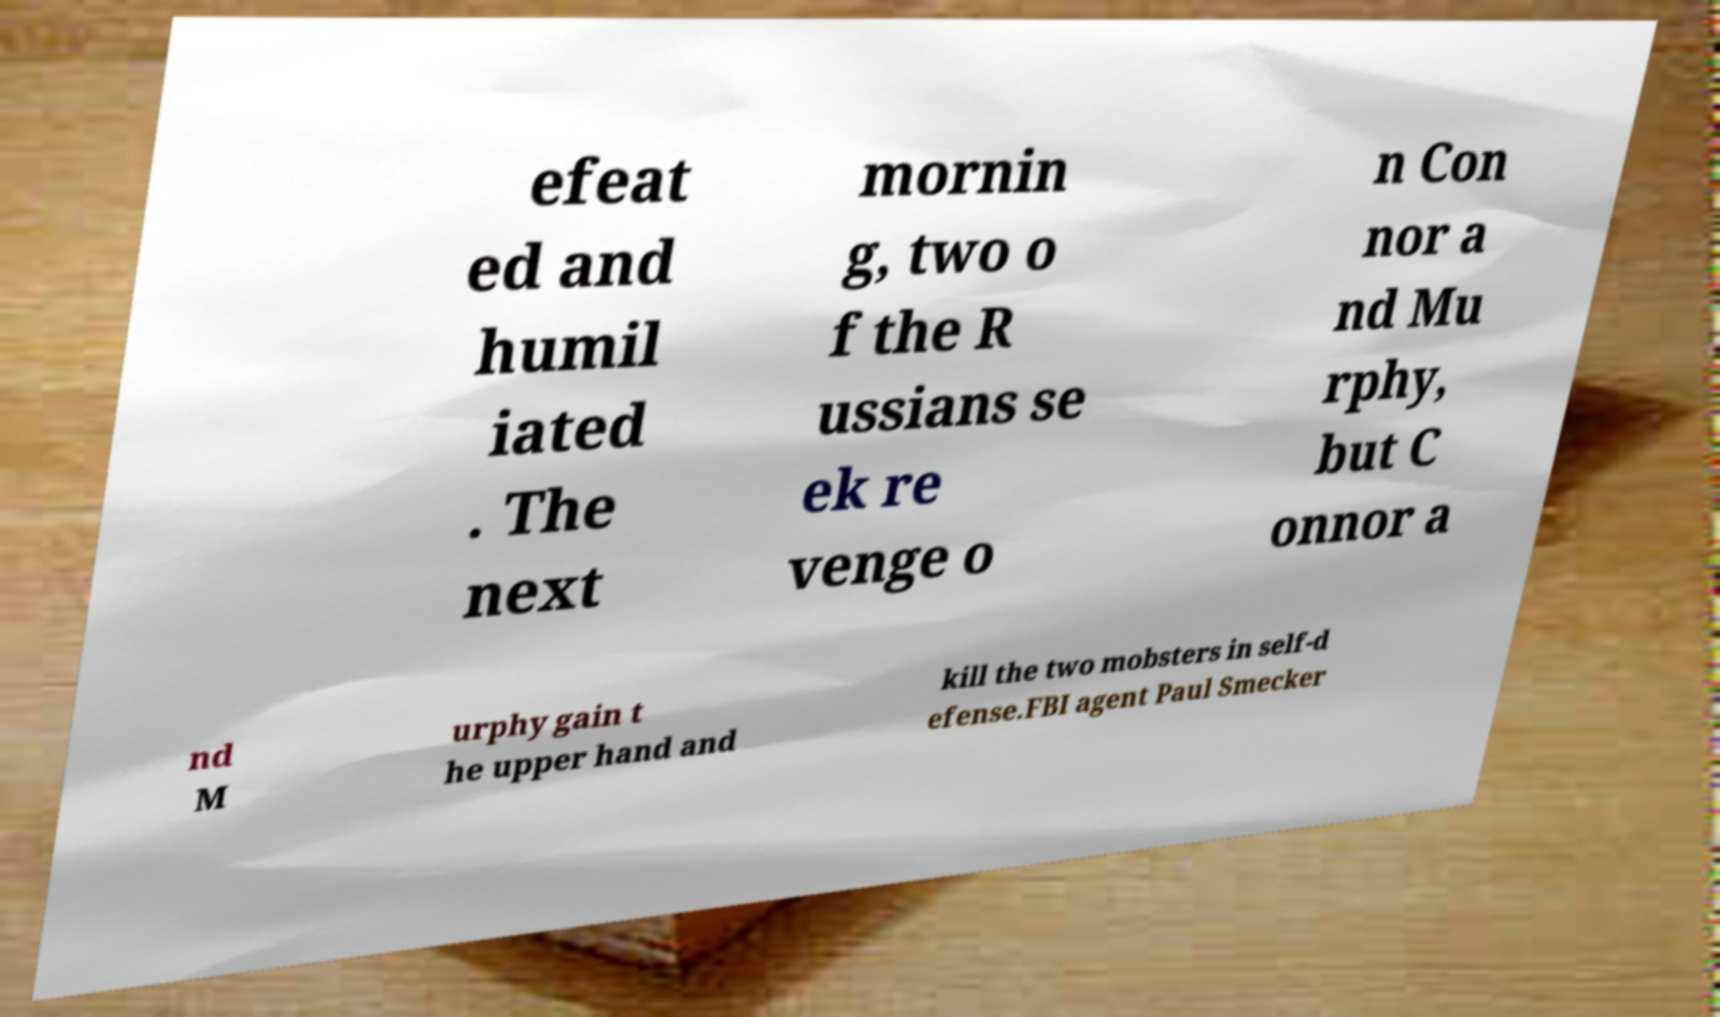Could you assist in decoding the text presented in this image and type it out clearly? efeat ed and humil iated . The next mornin g, two o f the R ussians se ek re venge o n Con nor a nd Mu rphy, but C onnor a nd M urphy gain t he upper hand and kill the two mobsters in self-d efense.FBI agent Paul Smecker 